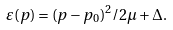Convert formula to latex. <formula><loc_0><loc_0><loc_500><loc_500>\varepsilon ( p ) = ( p - p _ { 0 } ) ^ { 2 } / 2 \mu + \Delta .</formula> 